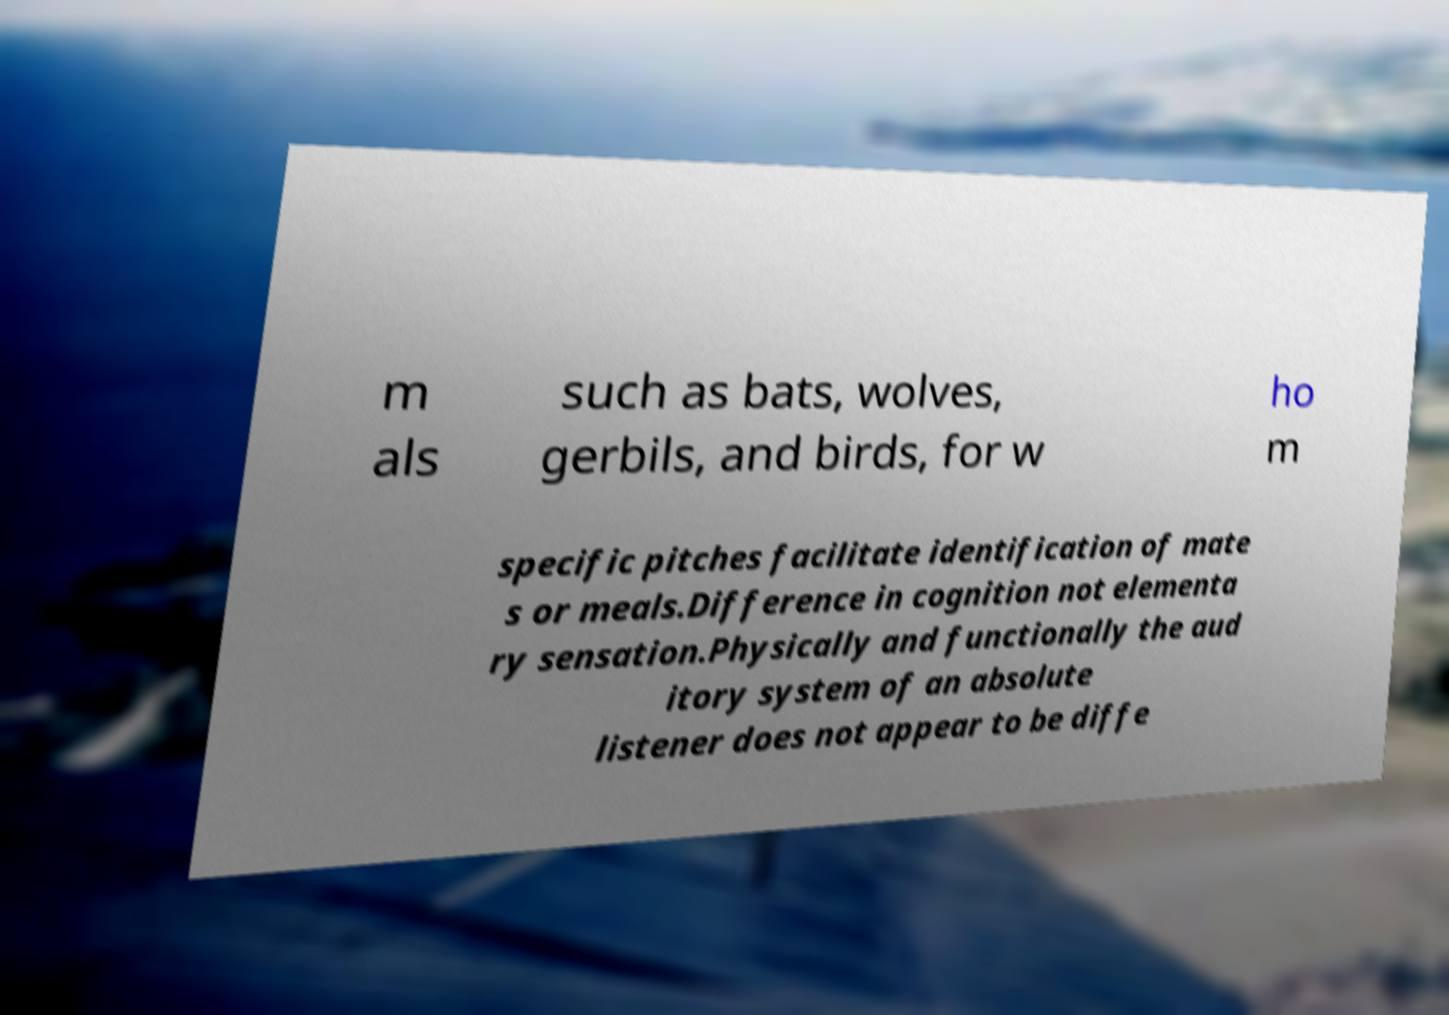Can you accurately transcribe the text from the provided image for me? m als such as bats, wolves, gerbils, and birds, for w ho m specific pitches facilitate identification of mate s or meals.Difference in cognition not elementa ry sensation.Physically and functionally the aud itory system of an absolute listener does not appear to be diffe 